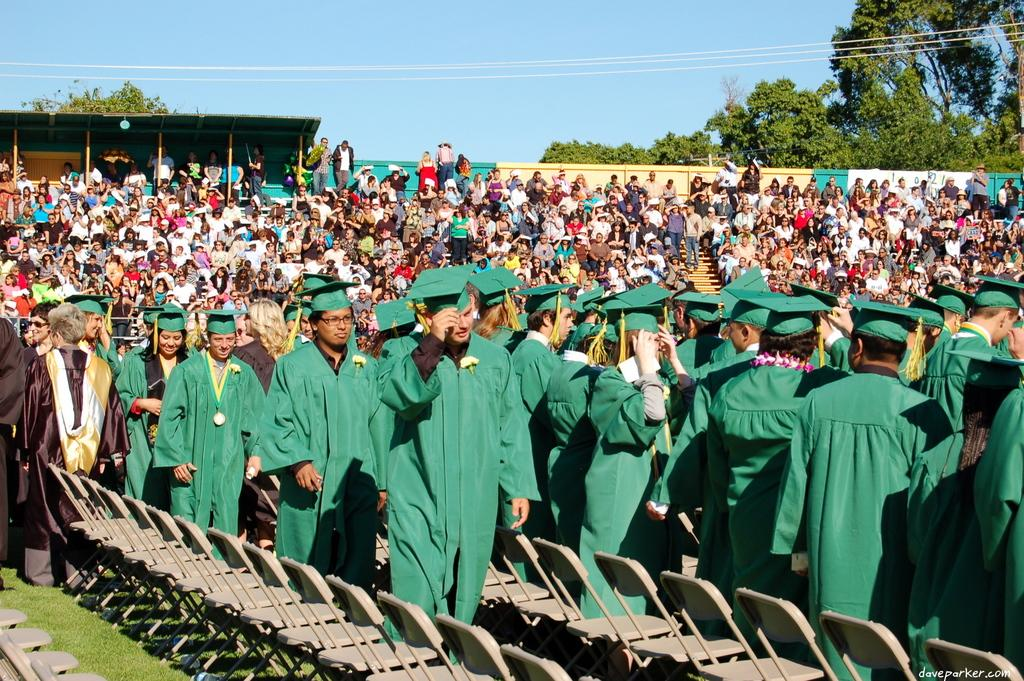How many people are in the image? There is a group of people in the image, but the exact number cannot be determined from the provided facts. What are the chairs used for in the image? The chairs are present on the grass, which suggests they are being used for seating. What type of structure is visible in the image? There is a shelter in the image. What is the purpose of the wall in the image? The purpose of the wall in the image cannot be determined from the provided facts. What type of items are present in the image? Clothes and objects are present in the image. What can be seen in the background of the image? Trees and the sky are visible in the background of the image. What is the tax rate for the territory depicted in the image? There is no information about a territory or tax rate in the image. What is the opinion of the people in the image about the current political situation? There is no information about the people's opinions or the political situation in the image. 